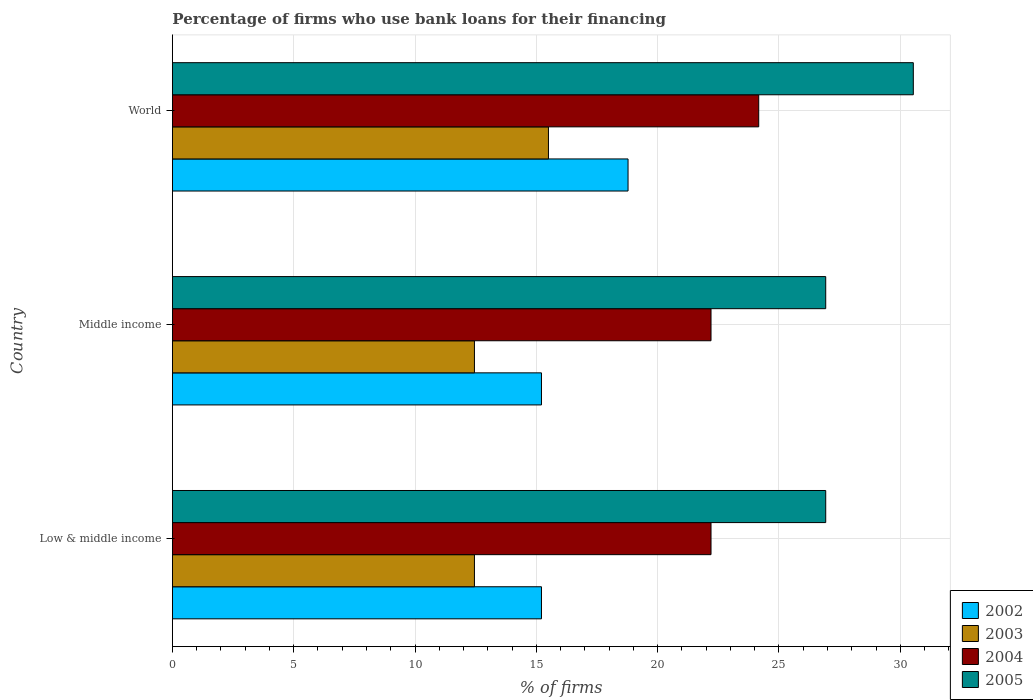How many groups of bars are there?
Give a very brief answer. 3. How many bars are there on the 1st tick from the bottom?
Offer a very short reply. 4. What is the percentage of firms who use bank loans for their financing in 2005 in World?
Offer a terse response. 30.54. Across all countries, what is the maximum percentage of firms who use bank loans for their financing in 2004?
Your response must be concise. 24.17. Across all countries, what is the minimum percentage of firms who use bank loans for their financing in 2002?
Offer a terse response. 15.21. In which country was the percentage of firms who use bank loans for their financing in 2003 minimum?
Offer a very short reply. Low & middle income. What is the total percentage of firms who use bank loans for their financing in 2005 in the graph?
Provide a succinct answer. 84.39. What is the difference between the percentage of firms who use bank loans for their financing in 2003 in Low & middle income and that in Middle income?
Give a very brief answer. 0. What is the difference between the percentage of firms who use bank loans for their financing in 2003 in Middle income and the percentage of firms who use bank loans for their financing in 2002 in World?
Your response must be concise. -6.33. What is the average percentage of firms who use bank loans for their financing in 2002 per country?
Ensure brevity in your answer.  16.4. What is the difference between the percentage of firms who use bank loans for their financing in 2004 and percentage of firms who use bank loans for their financing in 2003 in Middle income?
Your answer should be compact. 9.75. What is the ratio of the percentage of firms who use bank loans for their financing in 2004 in Middle income to that in World?
Offer a very short reply. 0.92. What is the difference between the highest and the second highest percentage of firms who use bank loans for their financing in 2002?
Your answer should be very brief. 3.57. What is the difference between the highest and the lowest percentage of firms who use bank loans for their financing in 2005?
Offer a very short reply. 3.61. In how many countries, is the percentage of firms who use bank loans for their financing in 2004 greater than the average percentage of firms who use bank loans for their financing in 2004 taken over all countries?
Ensure brevity in your answer.  1. Is it the case that in every country, the sum of the percentage of firms who use bank loans for their financing in 2005 and percentage of firms who use bank loans for their financing in 2002 is greater than the sum of percentage of firms who use bank loans for their financing in 2004 and percentage of firms who use bank loans for their financing in 2003?
Provide a short and direct response. Yes. Is it the case that in every country, the sum of the percentage of firms who use bank loans for their financing in 2005 and percentage of firms who use bank loans for their financing in 2002 is greater than the percentage of firms who use bank loans for their financing in 2003?
Provide a short and direct response. Yes. What is the difference between two consecutive major ticks on the X-axis?
Ensure brevity in your answer.  5. Are the values on the major ticks of X-axis written in scientific E-notation?
Keep it short and to the point. No. Does the graph contain any zero values?
Your response must be concise. No. Does the graph contain grids?
Offer a very short reply. Yes. Where does the legend appear in the graph?
Keep it short and to the point. Bottom right. How are the legend labels stacked?
Give a very brief answer. Vertical. What is the title of the graph?
Keep it short and to the point. Percentage of firms who use bank loans for their financing. What is the label or title of the X-axis?
Make the answer very short. % of firms. What is the label or title of the Y-axis?
Offer a terse response. Country. What is the % of firms in 2002 in Low & middle income?
Your answer should be compact. 15.21. What is the % of firms of 2003 in Low & middle income?
Your answer should be compact. 12.45. What is the % of firms in 2004 in Low & middle income?
Offer a terse response. 22.2. What is the % of firms in 2005 in Low & middle income?
Provide a succinct answer. 26.93. What is the % of firms in 2002 in Middle income?
Your answer should be very brief. 15.21. What is the % of firms in 2003 in Middle income?
Offer a terse response. 12.45. What is the % of firms in 2004 in Middle income?
Your answer should be compact. 22.2. What is the % of firms in 2005 in Middle income?
Make the answer very short. 26.93. What is the % of firms in 2002 in World?
Your answer should be compact. 18.78. What is the % of firms in 2003 in World?
Ensure brevity in your answer.  15.5. What is the % of firms of 2004 in World?
Make the answer very short. 24.17. What is the % of firms in 2005 in World?
Your answer should be very brief. 30.54. Across all countries, what is the maximum % of firms in 2002?
Keep it short and to the point. 18.78. Across all countries, what is the maximum % of firms of 2003?
Offer a terse response. 15.5. Across all countries, what is the maximum % of firms of 2004?
Make the answer very short. 24.17. Across all countries, what is the maximum % of firms of 2005?
Keep it short and to the point. 30.54. Across all countries, what is the minimum % of firms in 2002?
Keep it short and to the point. 15.21. Across all countries, what is the minimum % of firms of 2003?
Offer a terse response. 12.45. Across all countries, what is the minimum % of firms of 2005?
Your response must be concise. 26.93. What is the total % of firms of 2002 in the graph?
Your response must be concise. 49.21. What is the total % of firms of 2003 in the graph?
Your answer should be very brief. 40.4. What is the total % of firms of 2004 in the graph?
Offer a terse response. 68.57. What is the total % of firms of 2005 in the graph?
Offer a very short reply. 84.39. What is the difference between the % of firms in 2003 in Low & middle income and that in Middle income?
Make the answer very short. 0. What is the difference between the % of firms of 2004 in Low & middle income and that in Middle income?
Ensure brevity in your answer.  0. What is the difference between the % of firms in 2002 in Low & middle income and that in World?
Provide a succinct answer. -3.57. What is the difference between the % of firms in 2003 in Low & middle income and that in World?
Offer a terse response. -3.05. What is the difference between the % of firms in 2004 in Low & middle income and that in World?
Your answer should be compact. -1.97. What is the difference between the % of firms of 2005 in Low & middle income and that in World?
Offer a terse response. -3.61. What is the difference between the % of firms of 2002 in Middle income and that in World?
Provide a succinct answer. -3.57. What is the difference between the % of firms in 2003 in Middle income and that in World?
Make the answer very short. -3.05. What is the difference between the % of firms of 2004 in Middle income and that in World?
Your answer should be compact. -1.97. What is the difference between the % of firms of 2005 in Middle income and that in World?
Give a very brief answer. -3.61. What is the difference between the % of firms in 2002 in Low & middle income and the % of firms in 2003 in Middle income?
Your response must be concise. 2.76. What is the difference between the % of firms in 2002 in Low & middle income and the % of firms in 2004 in Middle income?
Provide a short and direct response. -6.99. What is the difference between the % of firms of 2002 in Low & middle income and the % of firms of 2005 in Middle income?
Ensure brevity in your answer.  -11.72. What is the difference between the % of firms of 2003 in Low & middle income and the % of firms of 2004 in Middle income?
Make the answer very short. -9.75. What is the difference between the % of firms in 2003 in Low & middle income and the % of firms in 2005 in Middle income?
Provide a short and direct response. -14.48. What is the difference between the % of firms in 2004 in Low & middle income and the % of firms in 2005 in Middle income?
Ensure brevity in your answer.  -4.73. What is the difference between the % of firms in 2002 in Low & middle income and the % of firms in 2003 in World?
Offer a terse response. -0.29. What is the difference between the % of firms in 2002 in Low & middle income and the % of firms in 2004 in World?
Make the answer very short. -8.95. What is the difference between the % of firms of 2002 in Low & middle income and the % of firms of 2005 in World?
Your response must be concise. -15.33. What is the difference between the % of firms in 2003 in Low & middle income and the % of firms in 2004 in World?
Your answer should be very brief. -11.72. What is the difference between the % of firms of 2003 in Low & middle income and the % of firms of 2005 in World?
Offer a very short reply. -18.09. What is the difference between the % of firms in 2004 in Low & middle income and the % of firms in 2005 in World?
Give a very brief answer. -8.34. What is the difference between the % of firms in 2002 in Middle income and the % of firms in 2003 in World?
Offer a very short reply. -0.29. What is the difference between the % of firms of 2002 in Middle income and the % of firms of 2004 in World?
Give a very brief answer. -8.95. What is the difference between the % of firms of 2002 in Middle income and the % of firms of 2005 in World?
Your answer should be compact. -15.33. What is the difference between the % of firms of 2003 in Middle income and the % of firms of 2004 in World?
Ensure brevity in your answer.  -11.72. What is the difference between the % of firms of 2003 in Middle income and the % of firms of 2005 in World?
Your answer should be very brief. -18.09. What is the difference between the % of firms in 2004 in Middle income and the % of firms in 2005 in World?
Provide a short and direct response. -8.34. What is the average % of firms in 2002 per country?
Your answer should be compact. 16.4. What is the average % of firms in 2003 per country?
Offer a terse response. 13.47. What is the average % of firms in 2004 per country?
Provide a succinct answer. 22.86. What is the average % of firms of 2005 per country?
Offer a very short reply. 28.13. What is the difference between the % of firms of 2002 and % of firms of 2003 in Low & middle income?
Offer a very short reply. 2.76. What is the difference between the % of firms of 2002 and % of firms of 2004 in Low & middle income?
Ensure brevity in your answer.  -6.99. What is the difference between the % of firms of 2002 and % of firms of 2005 in Low & middle income?
Keep it short and to the point. -11.72. What is the difference between the % of firms of 2003 and % of firms of 2004 in Low & middle income?
Keep it short and to the point. -9.75. What is the difference between the % of firms of 2003 and % of firms of 2005 in Low & middle income?
Offer a terse response. -14.48. What is the difference between the % of firms of 2004 and % of firms of 2005 in Low & middle income?
Keep it short and to the point. -4.73. What is the difference between the % of firms in 2002 and % of firms in 2003 in Middle income?
Ensure brevity in your answer.  2.76. What is the difference between the % of firms of 2002 and % of firms of 2004 in Middle income?
Ensure brevity in your answer.  -6.99. What is the difference between the % of firms in 2002 and % of firms in 2005 in Middle income?
Offer a very short reply. -11.72. What is the difference between the % of firms of 2003 and % of firms of 2004 in Middle income?
Give a very brief answer. -9.75. What is the difference between the % of firms in 2003 and % of firms in 2005 in Middle income?
Keep it short and to the point. -14.48. What is the difference between the % of firms in 2004 and % of firms in 2005 in Middle income?
Offer a terse response. -4.73. What is the difference between the % of firms in 2002 and % of firms in 2003 in World?
Give a very brief answer. 3.28. What is the difference between the % of firms of 2002 and % of firms of 2004 in World?
Your answer should be compact. -5.39. What is the difference between the % of firms in 2002 and % of firms in 2005 in World?
Make the answer very short. -11.76. What is the difference between the % of firms in 2003 and % of firms in 2004 in World?
Your answer should be very brief. -8.67. What is the difference between the % of firms in 2003 and % of firms in 2005 in World?
Your answer should be very brief. -15.04. What is the difference between the % of firms of 2004 and % of firms of 2005 in World?
Your response must be concise. -6.37. What is the ratio of the % of firms of 2002 in Low & middle income to that in Middle income?
Provide a short and direct response. 1. What is the ratio of the % of firms in 2002 in Low & middle income to that in World?
Your response must be concise. 0.81. What is the ratio of the % of firms of 2003 in Low & middle income to that in World?
Give a very brief answer. 0.8. What is the ratio of the % of firms in 2004 in Low & middle income to that in World?
Offer a very short reply. 0.92. What is the ratio of the % of firms of 2005 in Low & middle income to that in World?
Your response must be concise. 0.88. What is the ratio of the % of firms of 2002 in Middle income to that in World?
Your response must be concise. 0.81. What is the ratio of the % of firms of 2003 in Middle income to that in World?
Provide a succinct answer. 0.8. What is the ratio of the % of firms of 2004 in Middle income to that in World?
Offer a very short reply. 0.92. What is the ratio of the % of firms of 2005 in Middle income to that in World?
Give a very brief answer. 0.88. What is the difference between the highest and the second highest % of firms in 2002?
Provide a succinct answer. 3.57. What is the difference between the highest and the second highest % of firms in 2003?
Make the answer very short. 3.05. What is the difference between the highest and the second highest % of firms in 2004?
Offer a terse response. 1.97. What is the difference between the highest and the second highest % of firms in 2005?
Provide a succinct answer. 3.61. What is the difference between the highest and the lowest % of firms in 2002?
Your answer should be compact. 3.57. What is the difference between the highest and the lowest % of firms of 2003?
Your response must be concise. 3.05. What is the difference between the highest and the lowest % of firms of 2004?
Ensure brevity in your answer.  1.97. What is the difference between the highest and the lowest % of firms in 2005?
Give a very brief answer. 3.61. 